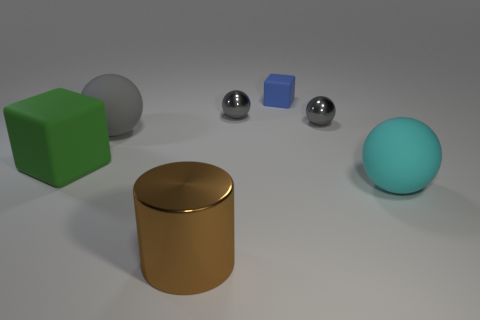Subtract all green blocks. How many gray balls are left? 3 Add 1 red metallic objects. How many objects exist? 8 Subtract all cubes. How many objects are left? 5 Add 1 large gray objects. How many large gray objects are left? 2 Add 3 purple matte blocks. How many purple matte blocks exist? 3 Subtract 0 yellow blocks. How many objects are left? 7 Subtract all tiny gray shiny cylinders. Subtract all cyan spheres. How many objects are left? 6 